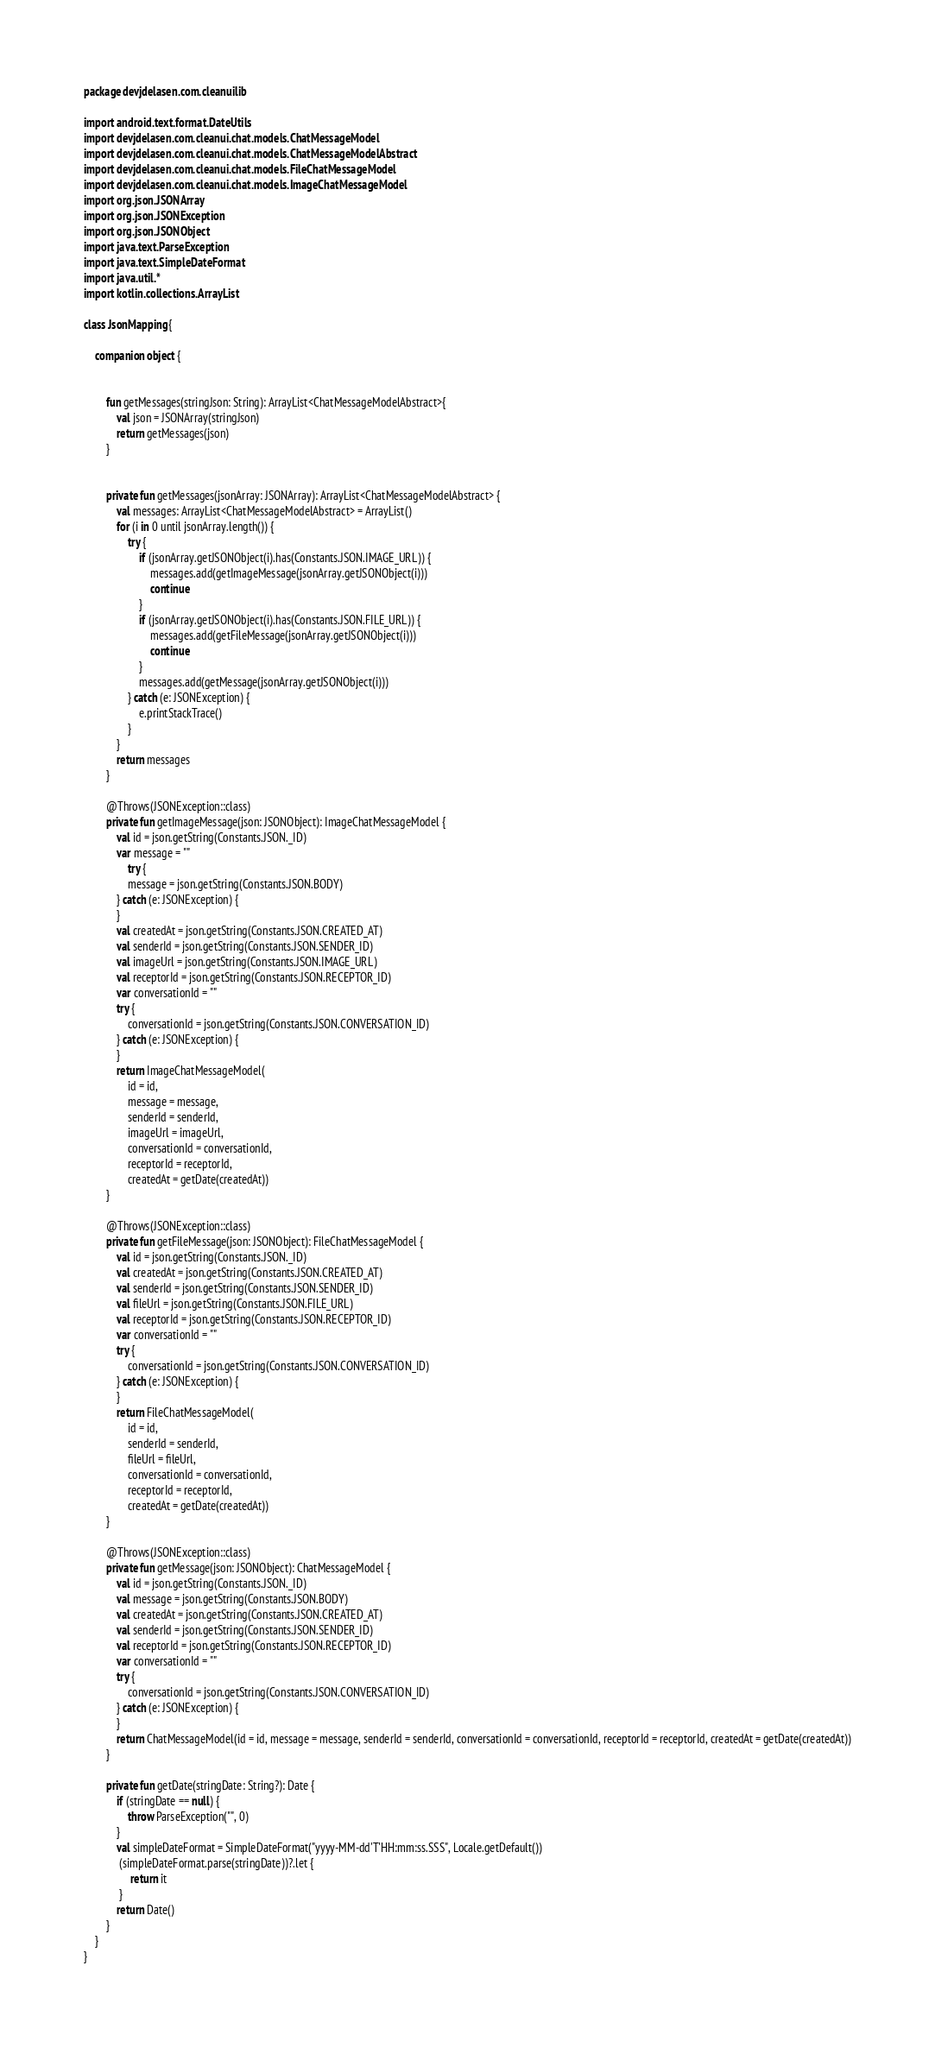<code> <loc_0><loc_0><loc_500><loc_500><_Kotlin_>package devjdelasen.com.cleanuilib

import android.text.format.DateUtils
import devjdelasen.com.cleanui.chat.models.ChatMessageModel
import devjdelasen.com.cleanui.chat.models.ChatMessageModelAbstract
import devjdelasen.com.cleanui.chat.models.FileChatMessageModel
import devjdelasen.com.cleanui.chat.models.ImageChatMessageModel
import org.json.JSONArray
import org.json.JSONException
import org.json.JSONObject
import java.text.ParseException
import java.text.SimpleDateFormat
import java.util.*
import kotlin.collections.ArrayList

class JsonMapping {

    companion object {


        fun getMessages(stringJson: String): ArrayList<ChatMessageModelAbstract>{
            val json = JSONArray(stringJson)
            return getMessages(json)
        }


        private fun getMessages(jsonArray: JSONArray): ArrayList<ChatMessageModelAbstract> {
            val messages: ArrayList<ChatMessageModelAbstract> = ArrayList()
            for (i in 0 until jsonArray.length()) {
                try {
                    if (jsonArray.getJSONObject(i).has(Constants.JSON.IMAGE_URL)) {
                        messages.add(getImageMessage(jsonArray.getJSONObject(i)))
                        continue
                    }
                    if (jsonArray.getJSONObject(i).has(Constants.JSON.FILE_URL)) {
                        messages.add(getFileMessage(jsonArray.getJSONObject(i)))
                        continue
                    }
                    messages.add(getMessage(jsonArray.getJSONObject(i)))
                } catch (e: JSONException) {
                    e.printStackTrace()
                }
            }
            return messages
        }

        @Throws(JSONException::class)
        private fun getImageMessage(json: JSONObject): ImageChatMessageModel {
            val id = json.getString(Constants.JSON._ID)
            var message = ""
                try {
                message = json.getString(Constants.JSON.BODY)
            } catch (e: JSONException) {
            }
            val createdAt = json.getString(Constants.JSON.CREATED_AT)
            val senderId = json.getString(Constants.JSON.SENDER_ID)
            val imageUrl = json.getString(Constants.JSON.IMAGE_URL)
            val receptorId = json.getString(Constants.JSON.RECEPTOR_ID)
            var conversationId = ""
            try {
                conversationId = json.getString(Constants.JSON.CONVERSATION_ID)
            } catch (e: JSONException) {
            }
            return ImageChatMessageModel(
                id = id,
                message = message,
                senderId = senderId,
                imageUrl = imageUrl,
                conversationId = conversationId,
                receptorId = receptorId,
                createdAt = getDate(createdAt))
        }

        @Throws(JSONException::class)
        private fun getFileMessage(json: JSONObject): FileChatMessageModel {
            val id = json.getString(Constants.JSON._ID)
            val createdAt = json.getString(Constants.JSON.CREATED_AT)
            val senderId = json.getString(Constants.JSON.SENDER_ID)
            val fileUrl = json.getString(Constants.JSON.FILE_URL)
            val receptorId = json.getString(Constants.JSON.RECEPTOR_ID)
            var conversationId = ""
            try {
                conversationId = json.getString(Constants.JSON.CONVERSATION_ID)
            } catch (e: JSONException) {
            }
            return FileChatMessageModel(
                id = id,
                senderId = senderId,
                fileUrl = fileUrl,
                conversationId = conversationId,
                receptorId = receptorId,
                createdAt = getDate(createdAt))
        }

        @Throws(JSONException::class)
        private fun getMessage(json: JSONObject): ChatMessageModel {
            val id = json.getString(Constants.JSON._ID)
            val message = json.getString(Constants.JSON.BODY)
            val createdAt = json.getString(Constants.JSON.CREATED_AT)
            val senderId = json.getString(Constants.JSON.SENDER_ID)
            val receptorId = json.getString(Constants.JSON.RECEPTOR_ID)
            var conversationId = ""
            try {
                conversationId = json.getString(Constants.JSON.CONVERSATION_ID)
            } catch (e: JSONException) {
            }
            return ChatMessageModel(id = id, message = message, senderId = senderId, conversationId = conversationId, receptorId = receptorId, createdAt = getDate(createdAt))
        }

        private fun getDate(stringDate: String?): Date {
            if (stringDate == null) {
                throw ParseException("", 0)
            }
            val simpleDateFormat = SimpleDateFormat("yyyy-MM-dd'T'HH:mm:ss.SSS", Locale.getDefault())
             (simpleDateFormat.parse(stringDate))?.let {
                 return it
             }
            return Date()
        }
    }
}</code> 